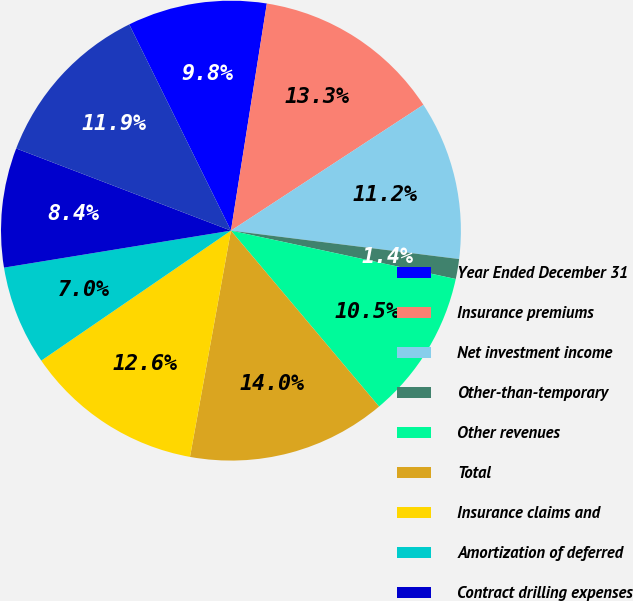<chart> <loc_0><loc_0><loc_500><loc_500><pie_chart><fcel>Year Ended December 31<fcel>Insurance premiums<fcel>Net investment income<fcel>Other-than-temporary<fcel>Other revenues<fcel>Total<fcel>Insurance claims and<fcel>Amortization of deferred<fcel>Contract drilling expenses<fcel>Other operating expenses (Note<nl><fcel>9.79%<fcel>13.29%<fcel>11.19%<fcel>1.4%<fcel>10.49%<fcel>13.99%<fcel>12.59%<fcel>6.99%<fcel>8.39%<fcel>11.89%<nl></chart> 